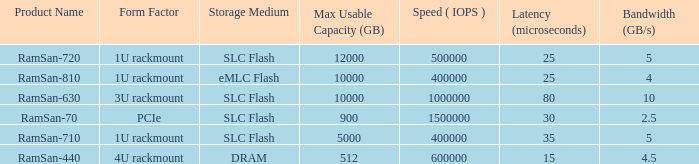What is the shape distortion for the range frequency of 10? 3U rackmount. 